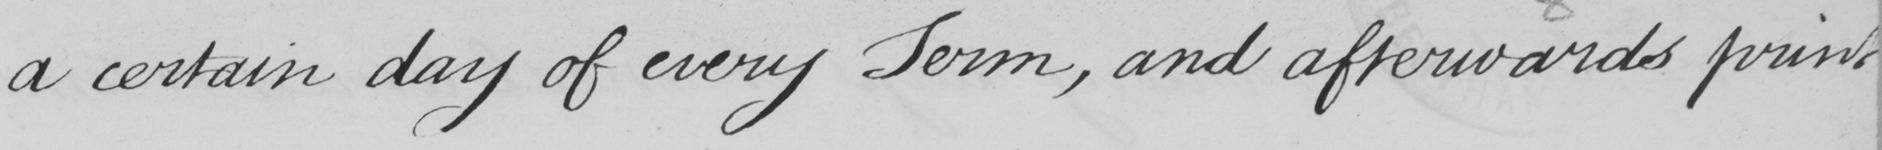Transcribe the text shown in this historical manuscript line. a certain day of every Term , and afterwards print 